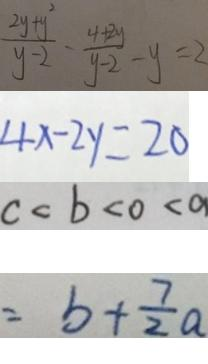Convert formula to latex. <formula><loc_0><loc_0><loc_500><loc_500>\frac { 2 y + y ^ { 2 } } { y - 2 } - \frac { 4 + 2 y } { y - 2 } - y = 2 
 4 x - 2 y = 2 0 
 c < b < 0 < a 
 = b + \frac { 7 } { 2 } a</formula> 